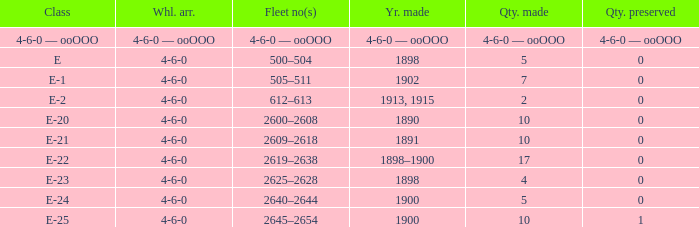What is the quantity preserved of the e-1 class? 0.0. 